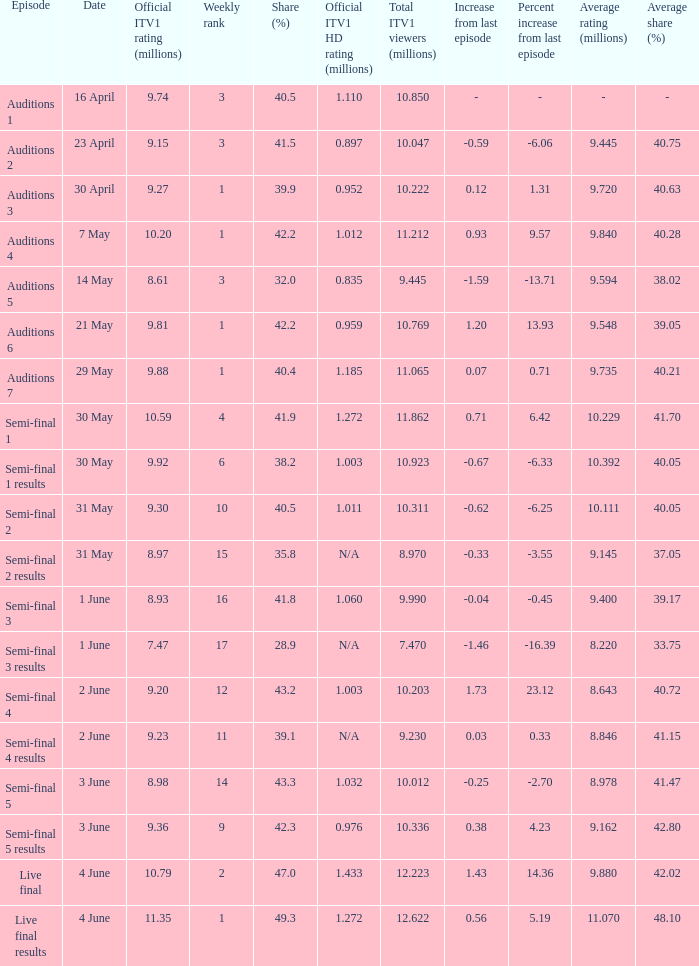What was the official ITV1 rating in millions of the Live Final Results episode? 11.35. 